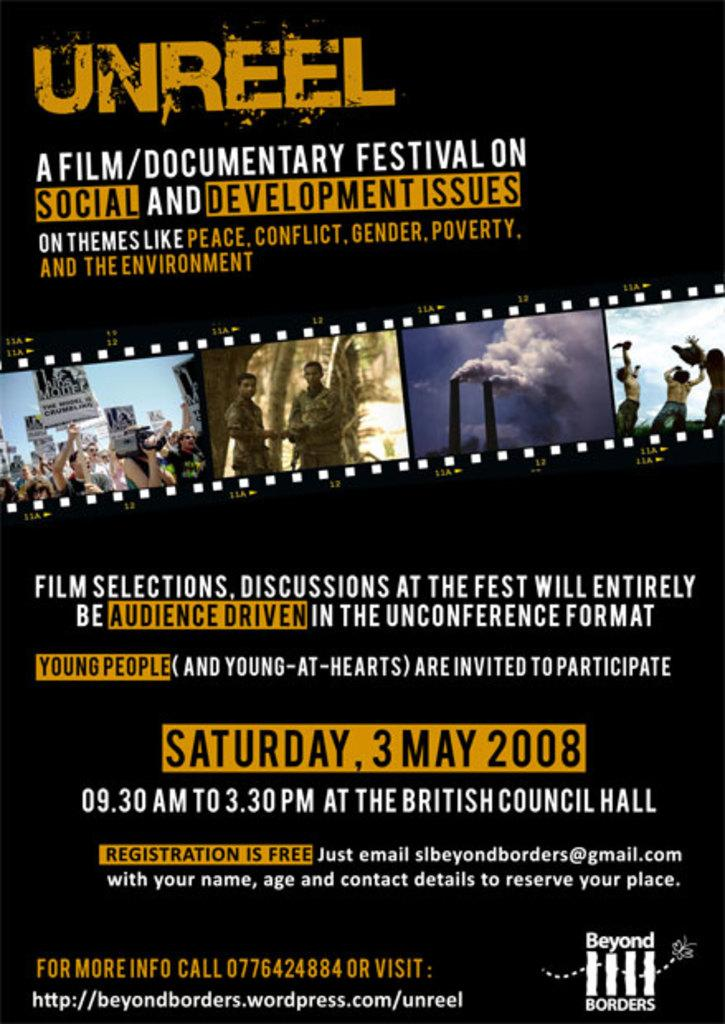<image>
Render a clear and concise summary of the photo. A poster for Unreel which is a film/Documentary festival. 